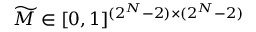<formula> <loc_0><loc_0><loc_500><loc_500>\widetilde { M } \in [ 0 , 1 ] ^ { ( 2 ^ { N } - 2 ) \times ( 2 ^ { N } - 2 ) }</formula> 